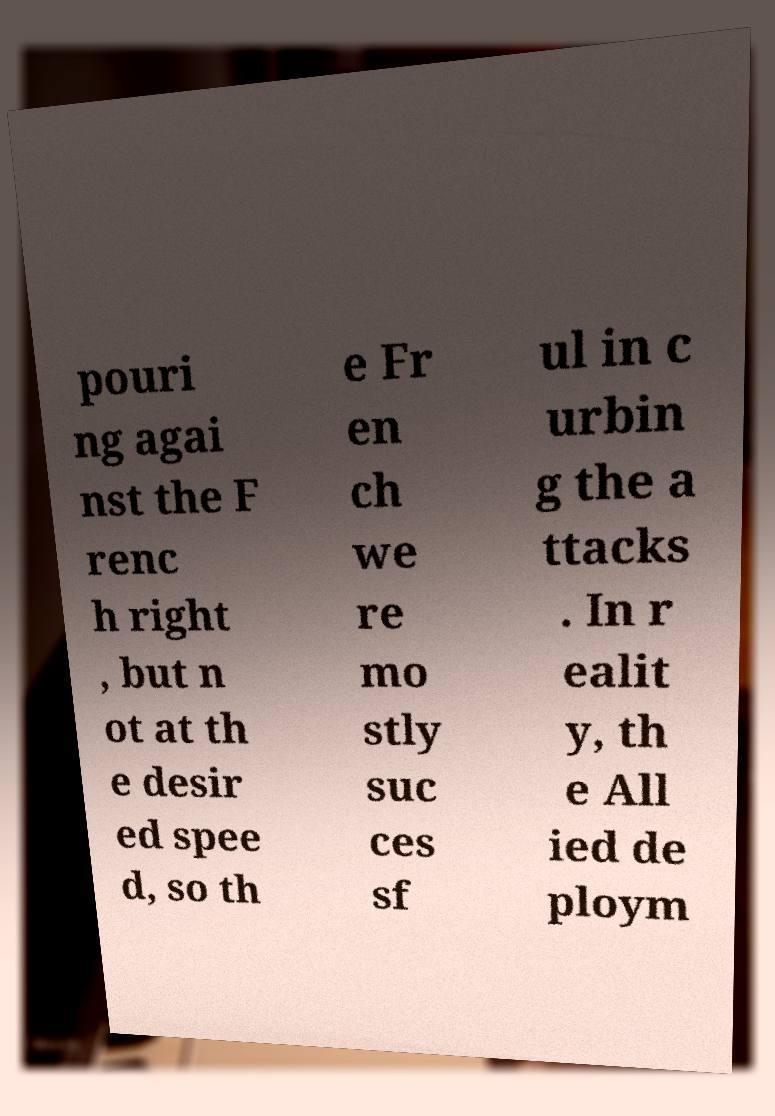Please read and relay the text visible in this image. What does it say? pouri ng agai nst the F renc h right , but n ot at th e desir ed spee d, so th e Fr en ch we re mo stly suc ces sf ul in c urbin g the a ttacks . In r ealit y, th e All ied de ploym 